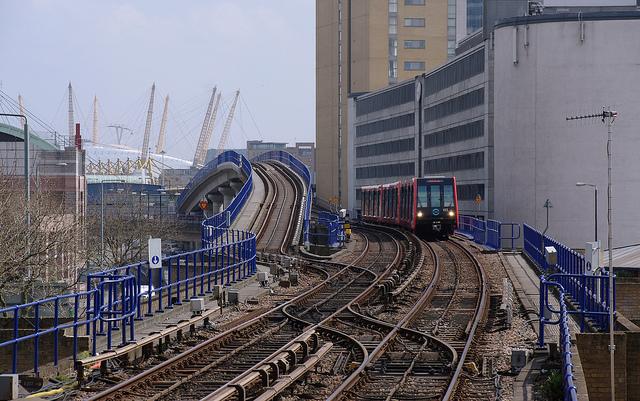How many fences are in the image?
Concise answer only. 4. What color is the train?
Quick response, please. Red. Is this the countryside?
Short answer required. No. How many train cars are on this train?
Answer briefly. 3. 